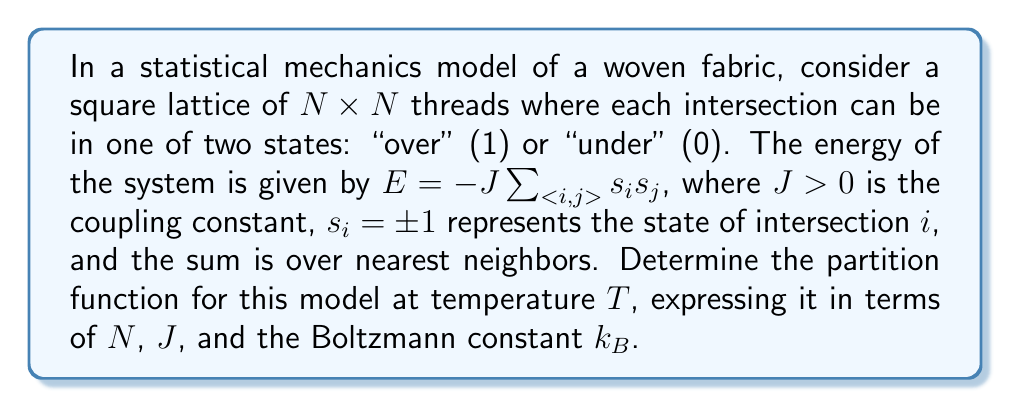Teach me how to tackle this problem. To determine the partition function for this lattice model of woven fabric, we'll follow these steps:

1) The partition function $Z$ is defined as:

   $$Z = \sum_{\text{all states}} e^{-\beta E}$$

   where $\beta = \frac{1}{k_B T}$

2) In our case, the energy is given by:

   $$E = -J\sum_{<i,j>} s_i s_j$$

3) Substituting this into the partition function:

   $$Z = \sum_{\text{all states}} \exp\left(\beta J\sum_{<i,j>} s_i s_j\right)$$

4) This model is equivalent to the 2D Ising model, for which an exact solution exists (derived by Onsager). The partition function for the 2D Ising model on a square lattice with periodic boundary conditions is:

   $$Z = (2\sinh(2\beta J))^{N^2/2} \prod_{k_x=1}^N \prod_{k_y=1}^N \left[\cosh^2(2\beta J) - \sinh(2\beta J)(\cos\frac{\pi k_x}{N} + \cos\frac{\pi k_y}{N})\right]^{1/2}$$

5) This expression is valid in the thermodynamic limit (large $N$). It's worth noting that this complex form arises from the non-trivial interactions between neighboring threads in the fabric.

6) The partition function encapsulates all possible configurations of the woven fabric, each weighted by its Boltzmann factor. This allows for the calculation of various thermodynamic properties of the fabric model, such as the average energy or specific heat.
Answer: $$Z = (2\sinh(2\beta J))^{N^2/2} \prod_{k_x=1}^N \prod_{k_y=1}^N \left[\cosh^2(2\beta J) - \sinh(2\beta J)(\cos\frac{\pi k_x}{N} + \cos\frac{\pi k_y}{N})\right]^{1/2}$$
where $\beta = \frac{1}{k_B T}$ 